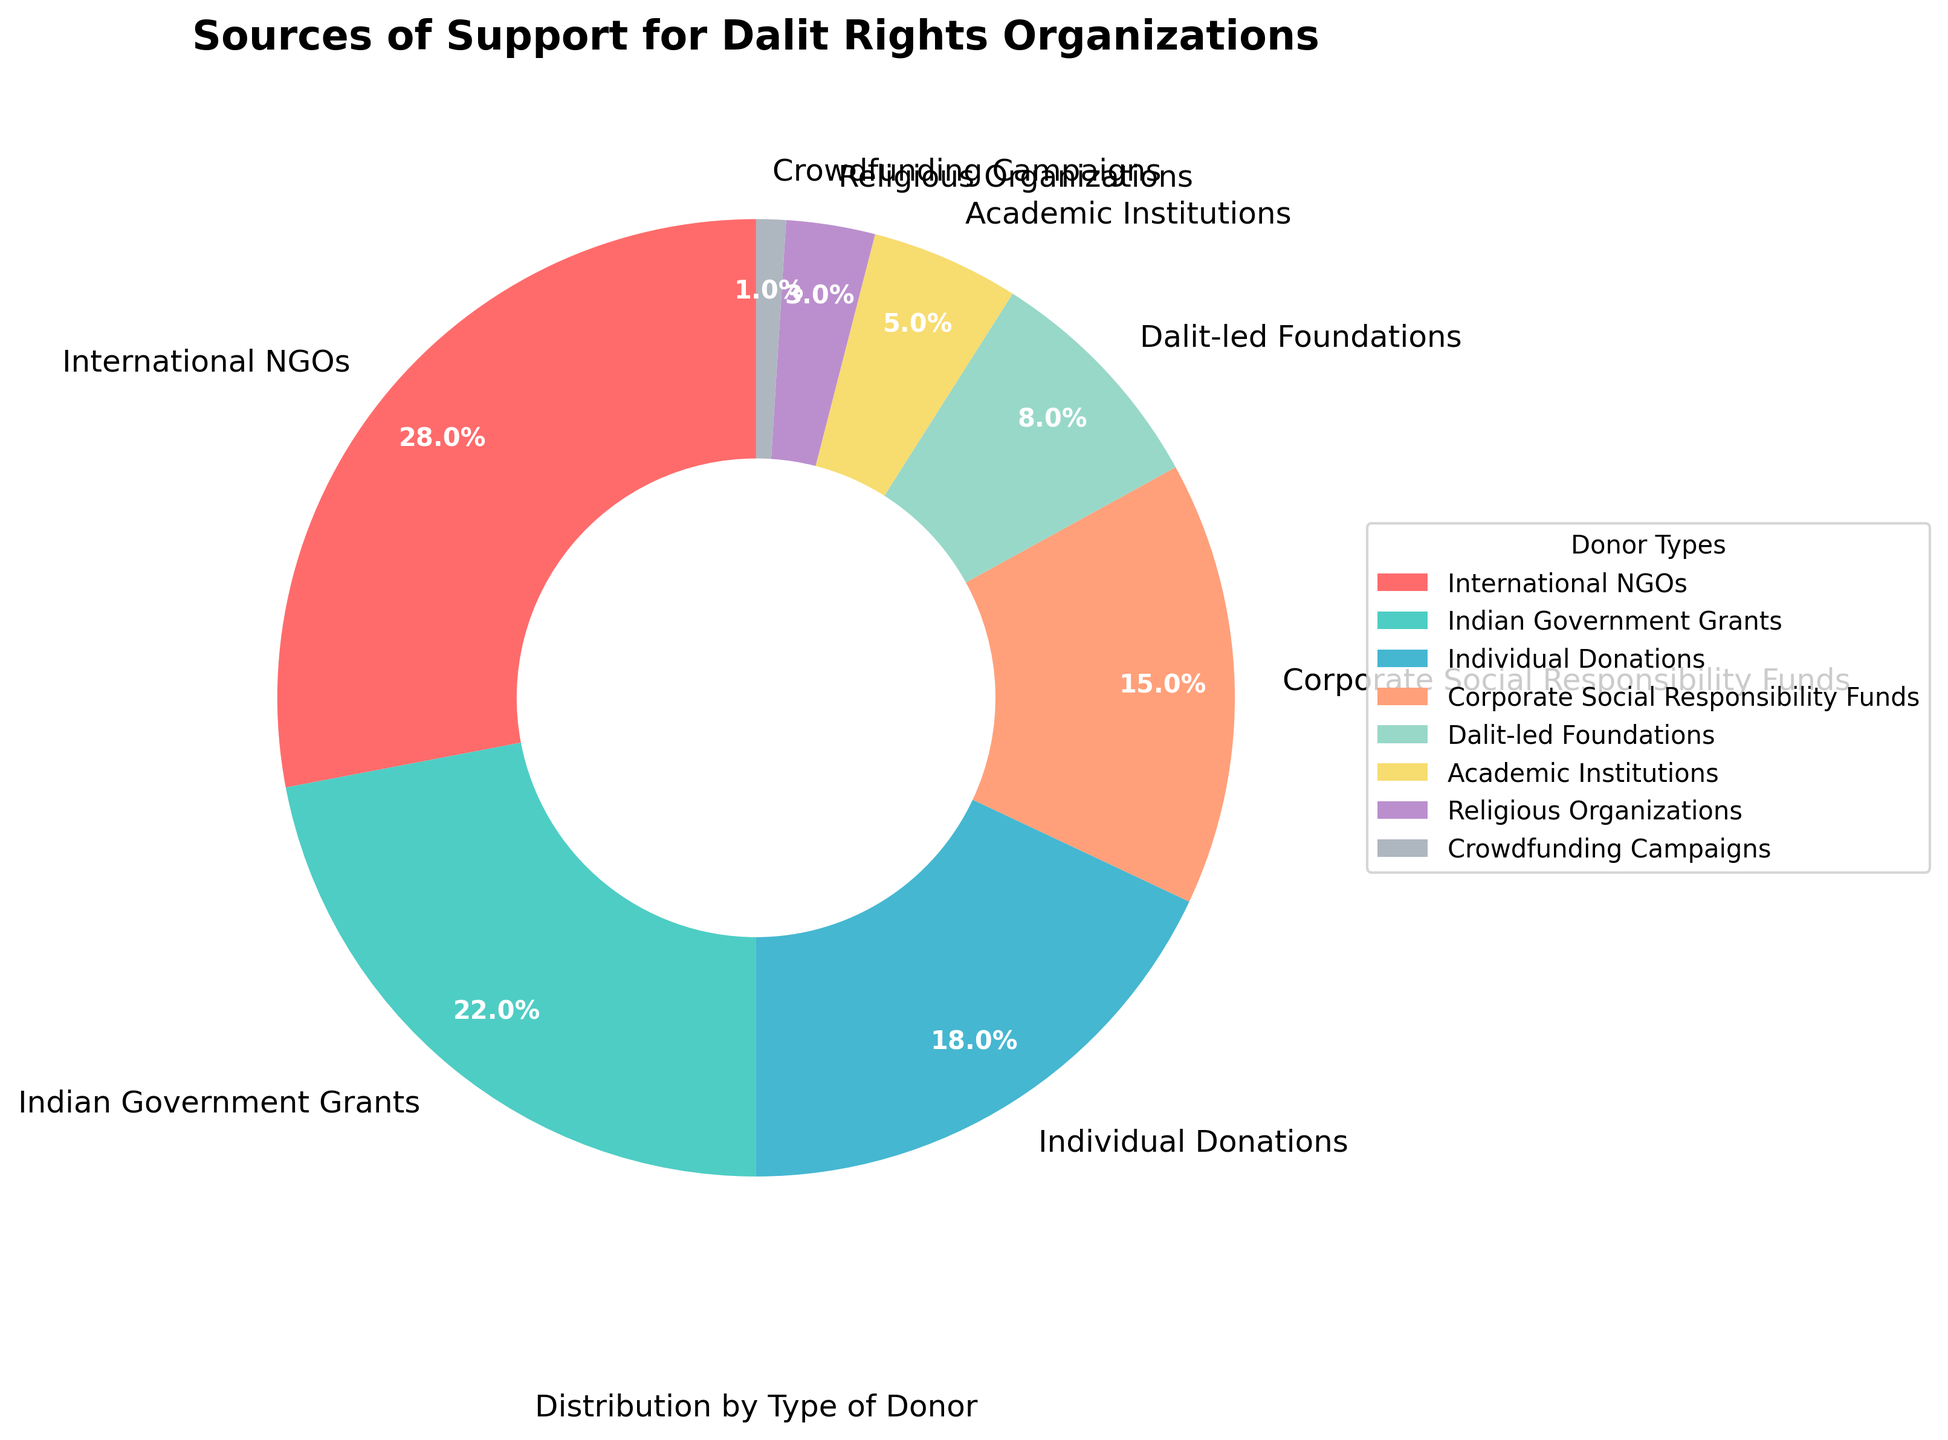What is the largest source of support for Dalit rights organizations? The pie chart shows that International NGOs are the largest source of support, with a slice labeled 28%.
Answer: International NGOs Which donor type contributes the least to Dalit rights organizations? The chart indicates that Crowdfunding Campaigns are the smallest, with a segment labeled 1%.
Answer: Crowdfunding Campaigns How much more do International NGOs contribute compared to Dalit-led Foundations? International NGOs contribute 28%, and Dalit-led Foundations contribute 8%, so the difference is 28% - 8% = 20%.
Answer: 20% What is the combined percentage of Indian Government Grants and Corporate Social Responsibility Funds? Indian Government Grants contribute 22%, and Corporate Social Responsibility Funds contribute 15%. The combined percentage is 22% + 15% = 37%.
Answer: 37% Which donor types contribute more than 20%? Two donor types contribute more than 20%: International NGOs with 28% and Indian Government Grants with 22%.
Answer: International NGOs, Indian Government Grants Compare the support from Academic Institutions to Religious Organizations. Which is larger, and by how much? Academic Institutions contribute 5%, while Religious Organizations contribute 3%. The difference is 5% - 3% = 2%, with Academic Institutions contributing more.
Answer: Academic Institutions, by 2% By what percentage do Individual Donations fall short of Corporate Social Responsibility Funds? Individual Donations contribute 18%, and Corporate Social Responsibility Funds contribute 15%. The shortfall is 18% - 15% = 3%.
Answer: 3% Which type of donor uses the color red in the pie chart? According to the custom color palette provided, the color red is used for International NGOs.
Answer: International NGOs What is the total contribution percentage of Dalit-led Foundations, Academic Institutions, and Religious Organizations combined? Dalit-led Foundations contribute 8%, Academic Institutions contribute 5%, and Religious Organizations contribute 3%. The total contribution is 8% + 5% + 3% = 16%.
Answer: 16% Which types of donors contribute less than 10% each, and what is their total contribution? Dalit-led Foundations (8%), Academic Institutions (5%), Religious Organizations (3%), and Crowdfunding Campaigns (1%) each contribute less than 10%. The total contribution is 8% + 5% + 3% + 1% = 17%.
Answer: 17% 